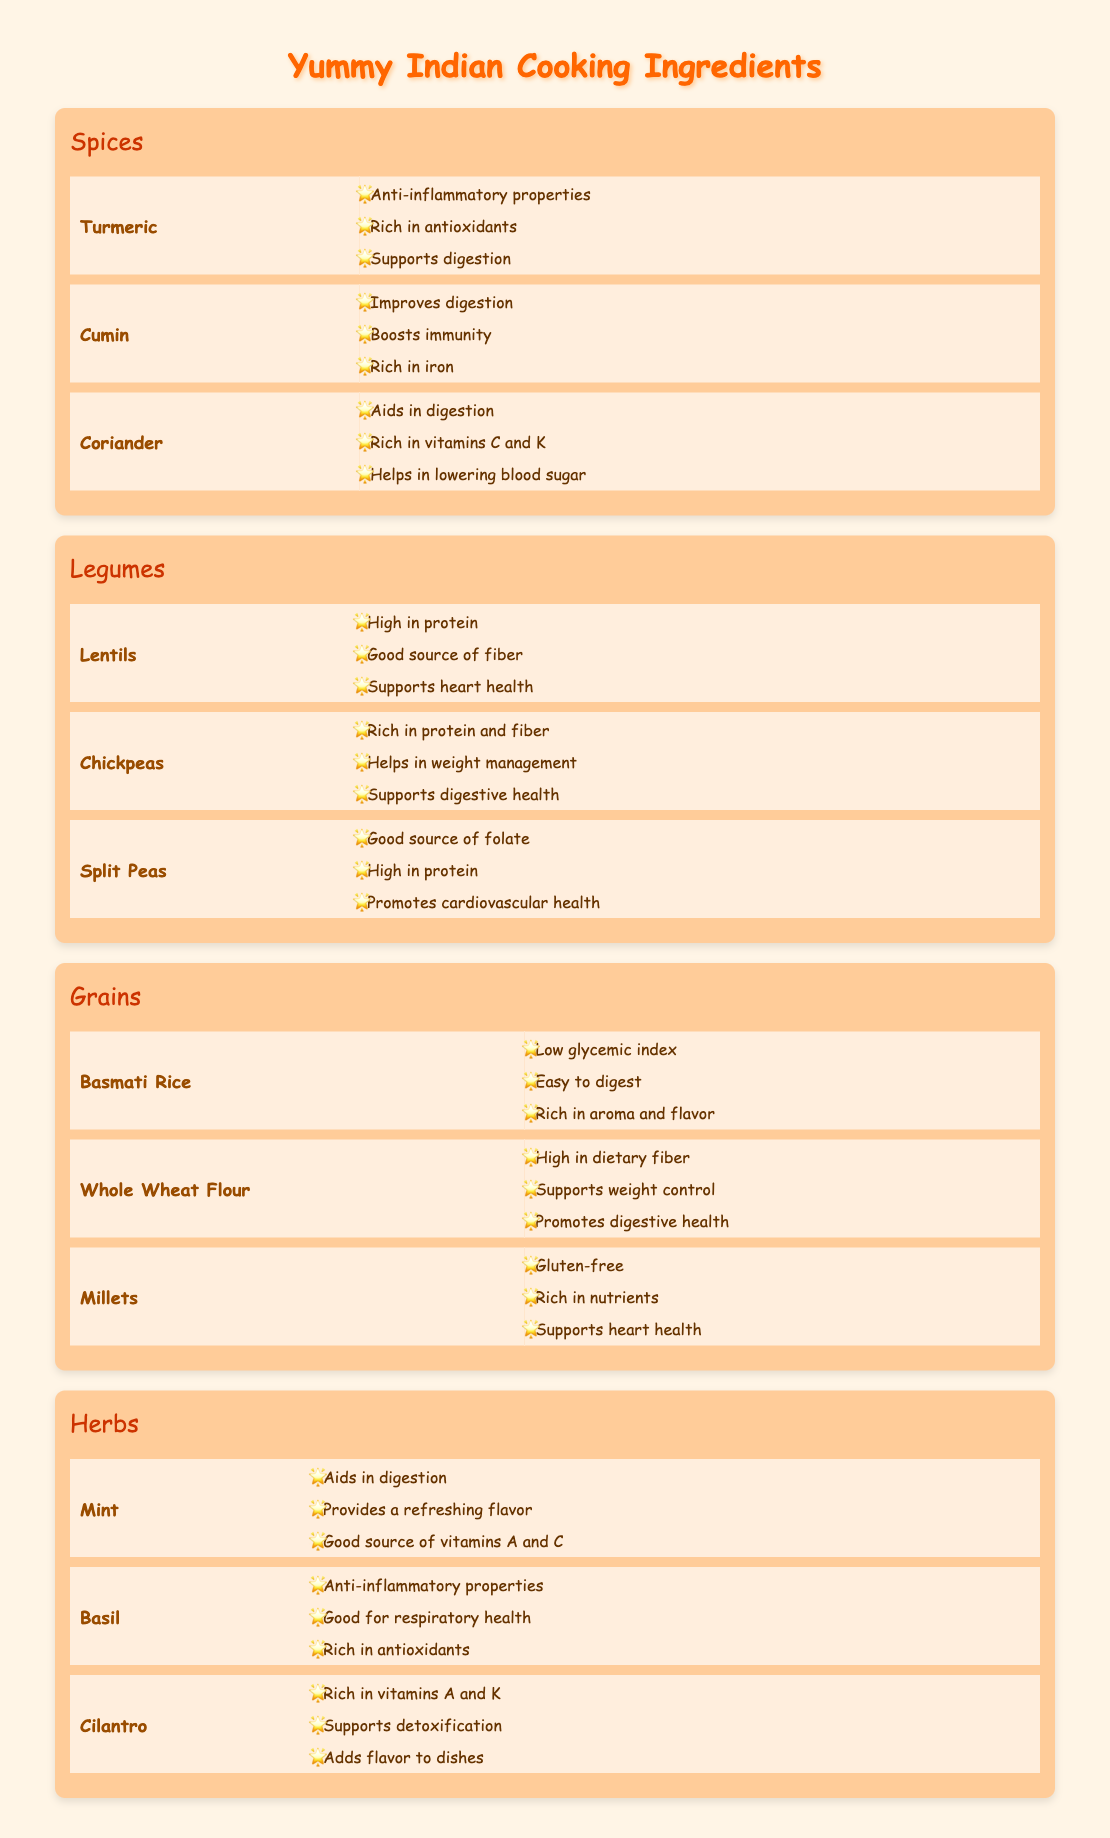What are the benefits of Turmeric? The table shows the benefits of Turmeric under the Spices category. They include anti-inflammatory properties, being rich in antioxidants, and supporting digestion.
Answer: Anti-inflammatory properties, rich in antioxidants, supports digestion Which ingredient aids in digestion and is also a herb? Looking at the Herbs section, both Mint and Cilantro aid in digestion. Therefore, the answer should reflect that connection.
Answer: Mint and Cilantro How many benefits does Cumin have listed? In the Spices section, Cumin has three benefits listed: improves digestion, boosts immunity, and rich in iron. By counting them, we find the total is three.
Answer: 3 Is Chickpeas high in protein? The table indicates that Chickpeas are rich in protein and fiber, which means they are indeed high in protein.
Answer: Yes Which ingredient among the Grains is gluten-free? The table in the Grains section lists Millets as gluten-free. By checking the benefits under Grains, we can confirm Millets meets this criterion.
Answer: Millets What is the average number of benefits for Legumes? The table shows that Lentils have 3 benefits, Chickpeas have 3, and Split Peas have 3. The average is calculated by adding them (3+3+3 = 9) and dividing by the number of ingredients (9/3 = 3).
Answer: 3 Does Basil have benefits related to heart health? In the Herbs section, the benefits listed for Basil are anti-inflammatory properties, good for respiratory health, and rich in antioxidants. There are no mentions of heart health. Therefore, the answer is no.
Answer: No Which ingredient has both digestive health and weight management benefits? By examining the Legumes section, Chickpeas are noted to help with weight management and also support digestive health. Therefore, Chickpeas fit both criteria.
Answer: Chickpeas 